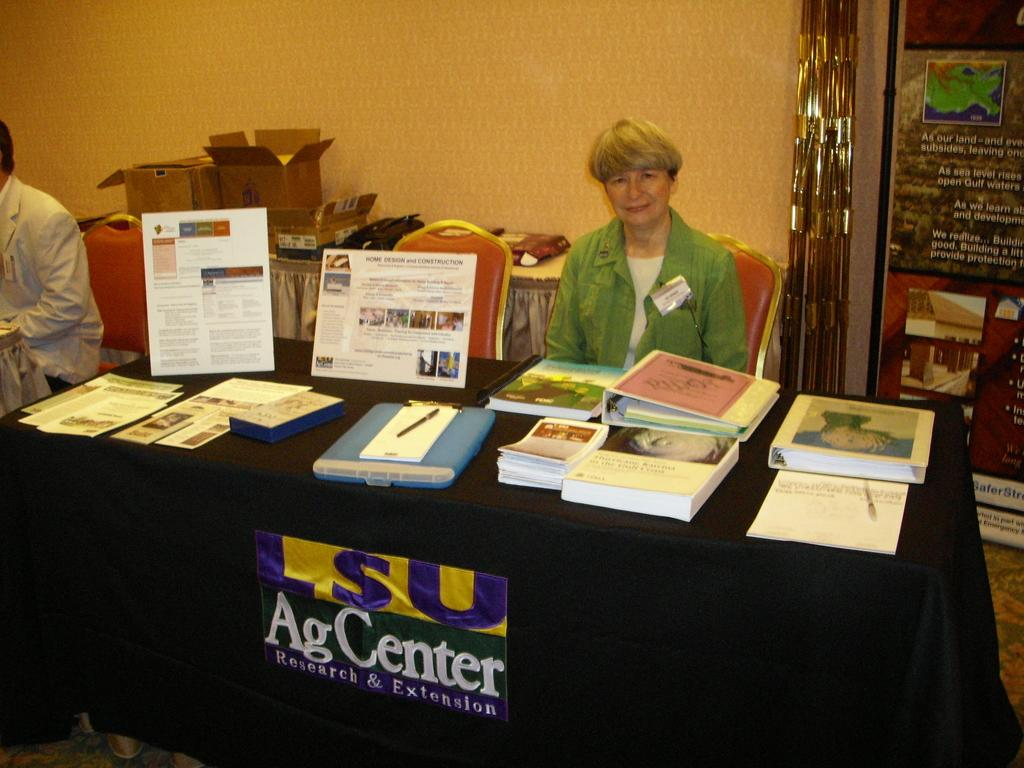<image>
Create a compact narrative representing the image presented. A woman sits behind a table for the LSU Ag Center. 